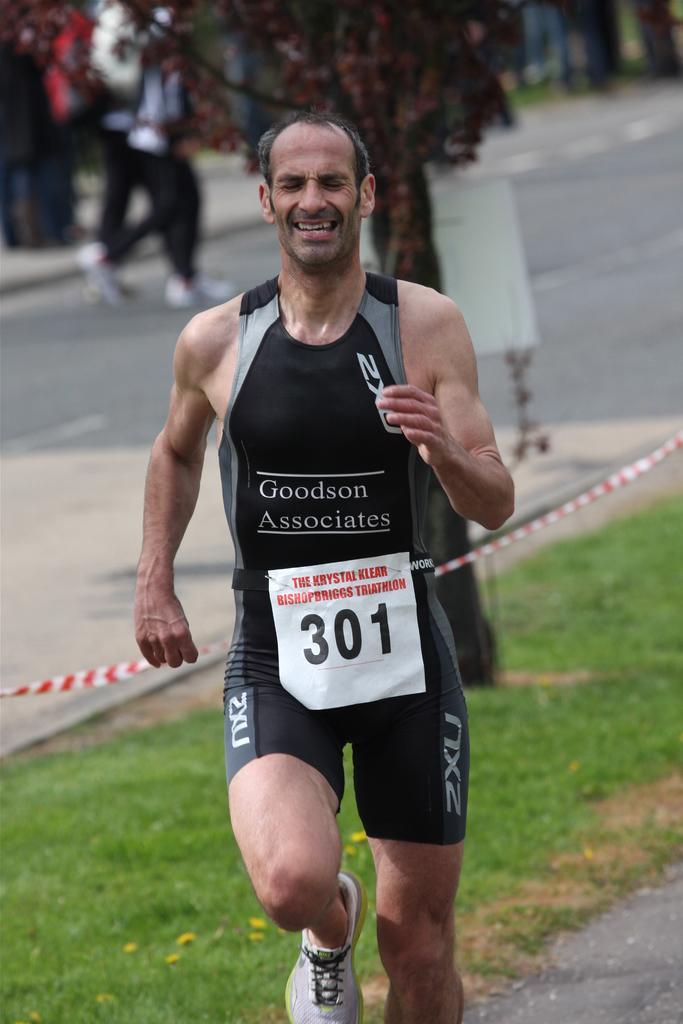<image>
Write a terse but informative summary of the picture. A triathlon runner wears a Goodson Associates outfit and the number 301. 